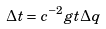<formula> <loc_0><loc_0><loc_500><loc_500>\Delta t = c ^ { - 2 } g t \Delta q</formula> 